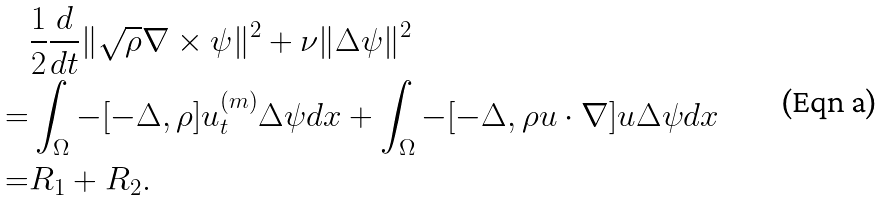<formula> <loc_0><loc_0><loc_500><loc_500>& \frac { 1 } { 2 } \frac { d } { d t } \| \sqrt { \rho } \nabla \times \psi \| ^ { 2 } + \nu \| \Delta \psi \| ^ { 2 } \\ = & \int _ { \Omega } - [ - \Delta , \rho ] u ^ { ( m ) } _ { t } \Delta \psi d x + \int _ { \Omega } - [ - \Delta , \rho u \cdot \nabla ] u \Delta \psi d x \\ = & R _ { 1 } + R _ { 2 } .</formula> 